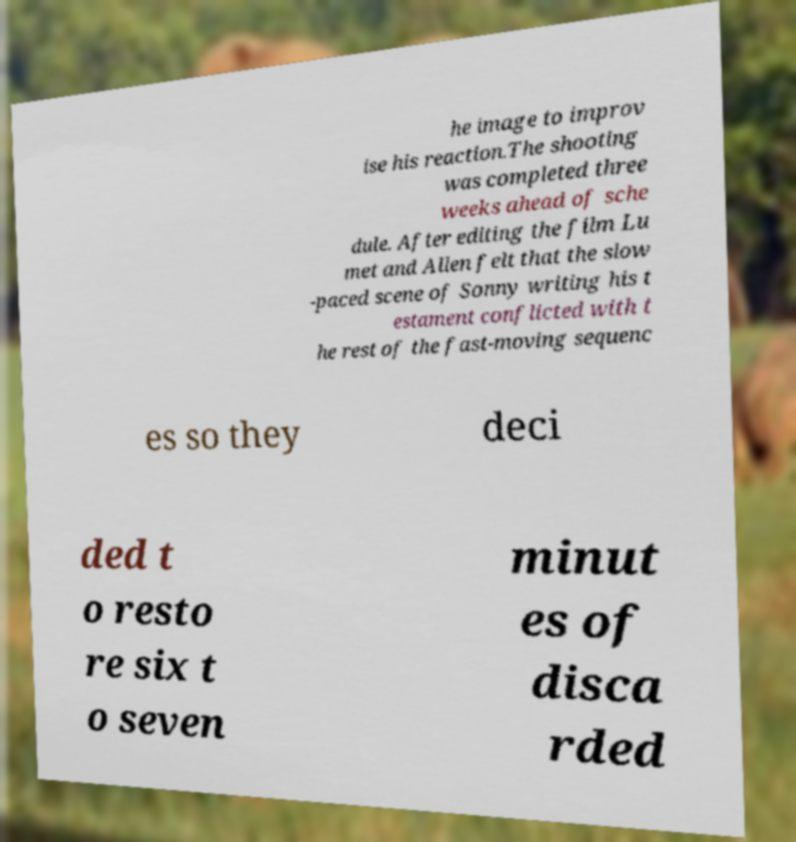Please identify and transcribe the text found in this image. he image to improv ise his reaction.The shooting was completed three weeks ahead of sche dule. After editing the film Lu met and Allen felt that the slow -paced scene of Sonny writing his t estament conflicted with t he rest of the fast-moving sequenc es so they deci ded t o resto re six t o seven minut es of disca rded 